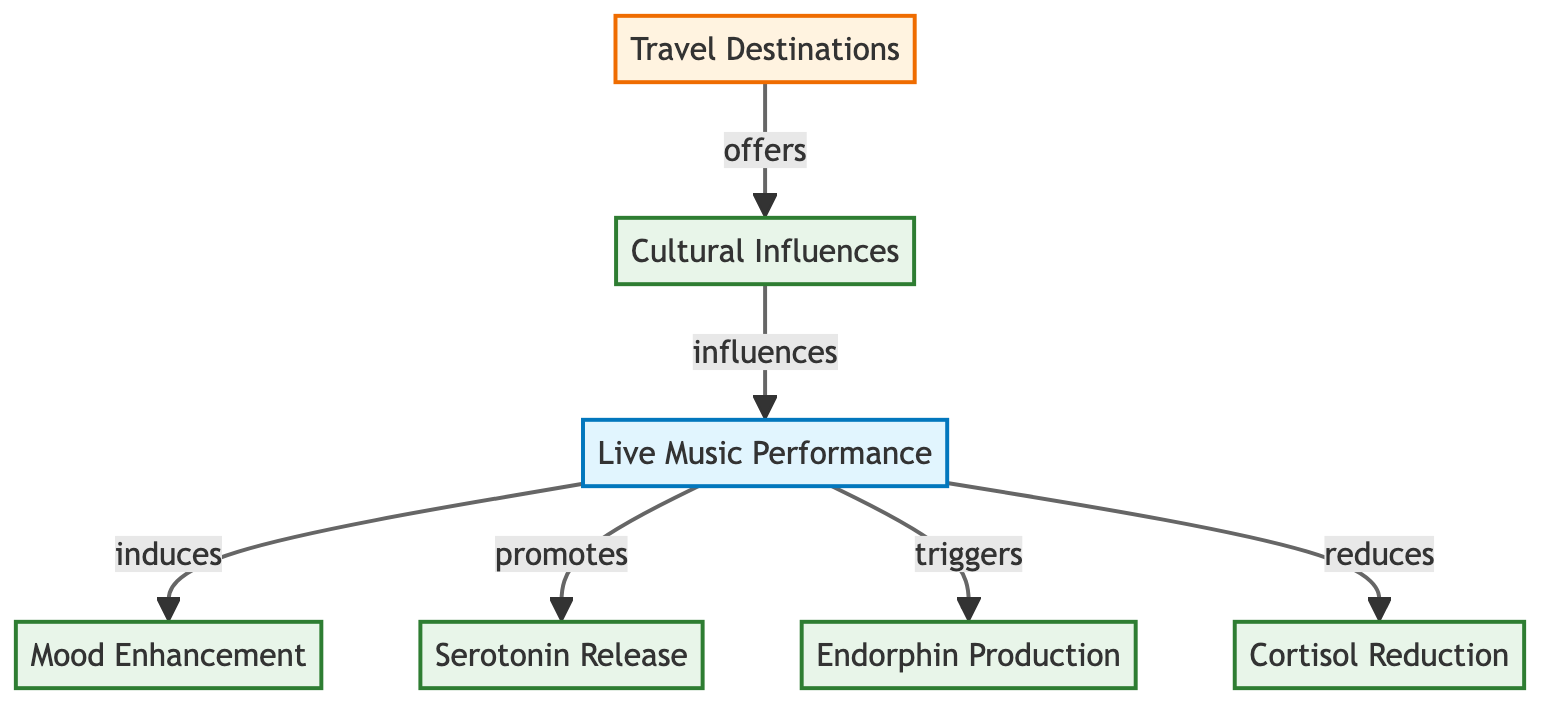What is the main trigger for mood enhancement in this diagram? The diagram indicates that "Live Music Performance" induces "Mood Enhancement." Thus, the key source of mood enhancement is the live music performance itself.
Answer: Live Music Performance How many nodes are represented in the diagram? By counting the shapes displayed, there are seven distinct nodes: one oval (Live Music Performance), five rectangles (Mood Enhancement, Serotonin Release, Endorphin Production, Cortisol Reduction, Cultural Influences), and one pentagon (Travel Destinations).
Answer: 7 What effect does live music have on cortisol levels according to the diagram? The diagram states that "Live Music Performance" reduces "Cortisol." This indicates that attending live music can lead to a decrease in cortisol levels.
Answer: Cortisol Reduction Which node indicates the influence of travel destinations on cultural aspects in the diagram? The node labeled "Travel Destinations" illustrates that it "offers" cultural influences, indicating that travel destinations play a critical role in shaping cultural experiences that can affect live music performances.
Answer: Cultural Influences What is the relationship between cultural influences and live music performances in the diagram? The diagram shows that cultural influences "influence" live music performances. This indicates that the culture of a destination plays a significant role in the nature of the live music experience.
Answer: influences What biochemical response results from live music as per the diagram? The diagram outlines that live music promotes the release of serotonin, triggers endorphin production, and reduces cortisol. Each of these responses indicates a positive biochemical reaction to live music.
Answer: Serotonin Release, Endorphin Production, Cortisol Reduction What type of diagram is this? This is a biomedical diagram, as it illustrates the biochemical responses of the human body to live music performances and their relationships.
Answer: Biomedical Diagram 